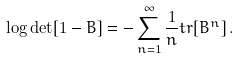Convert formula to latex. <formula><loc_0><loc_0><loc_500><loc_500>\log \det [ 1 - B ] = - \sum ^ { \infty } _ { n = 1 } \frac { 1 } { n } t r [ B ^ { n } ] \, .</formula> 